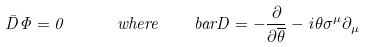<formula> <loc_0><loc_0><loc_500><loc_500>\bar { D } \Phi = 0 \quad \ \ w h e r e \quad b a r D = - \frac { \partial } { \partial \overline { \theta } } - i \theta \sigma ^ { \mu } \partial _ { \mu }</formula> 